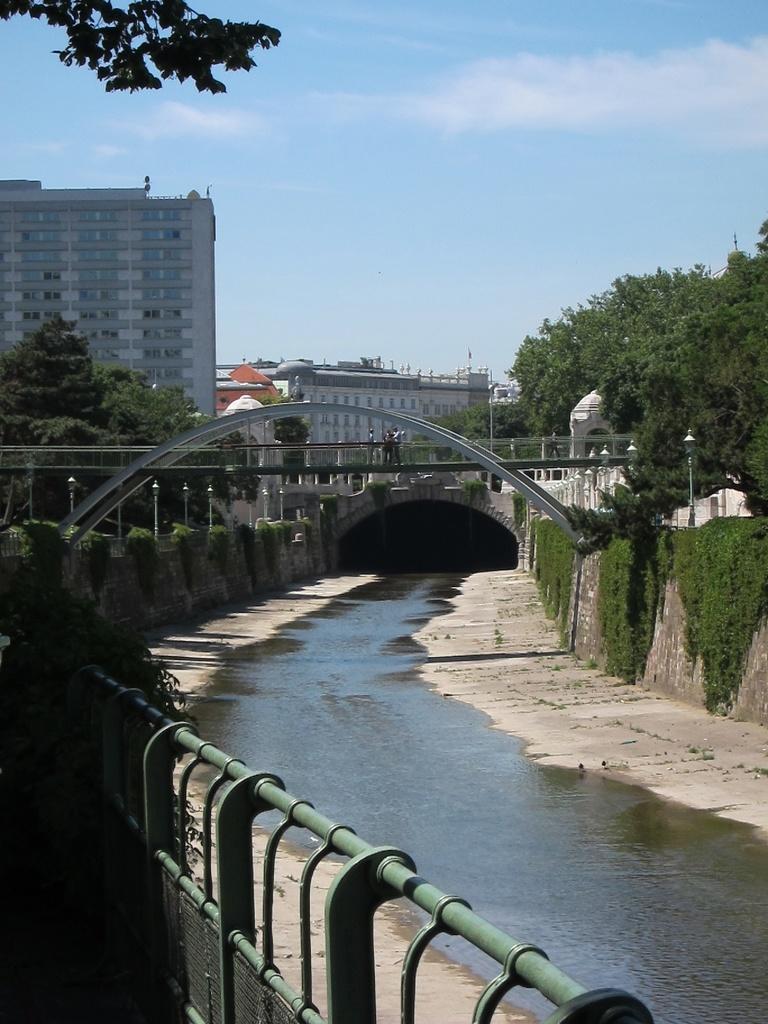Describe this image in one or two sentences. In this image we can see a tunnel and a bridge. On the bridge we can see few persons. In front of the bridge we can see the water, poles with lights and the walls. On the walls there are groups of trees. At the bottom we can see a fencing. Behind the bridge we can see a group of trees and buildings. At the top we can see the sky. 